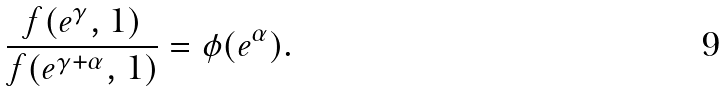Convert formula to latex. <formula><loc_0><loc_0><loc_500><loc_500>\frac { f ( e ^ { \gamma } , 1 ) } { f ( e ^ { \gamma + \alpha } , 1 ) } = \phi ( e ^ { \alpha } ) .</formula> 